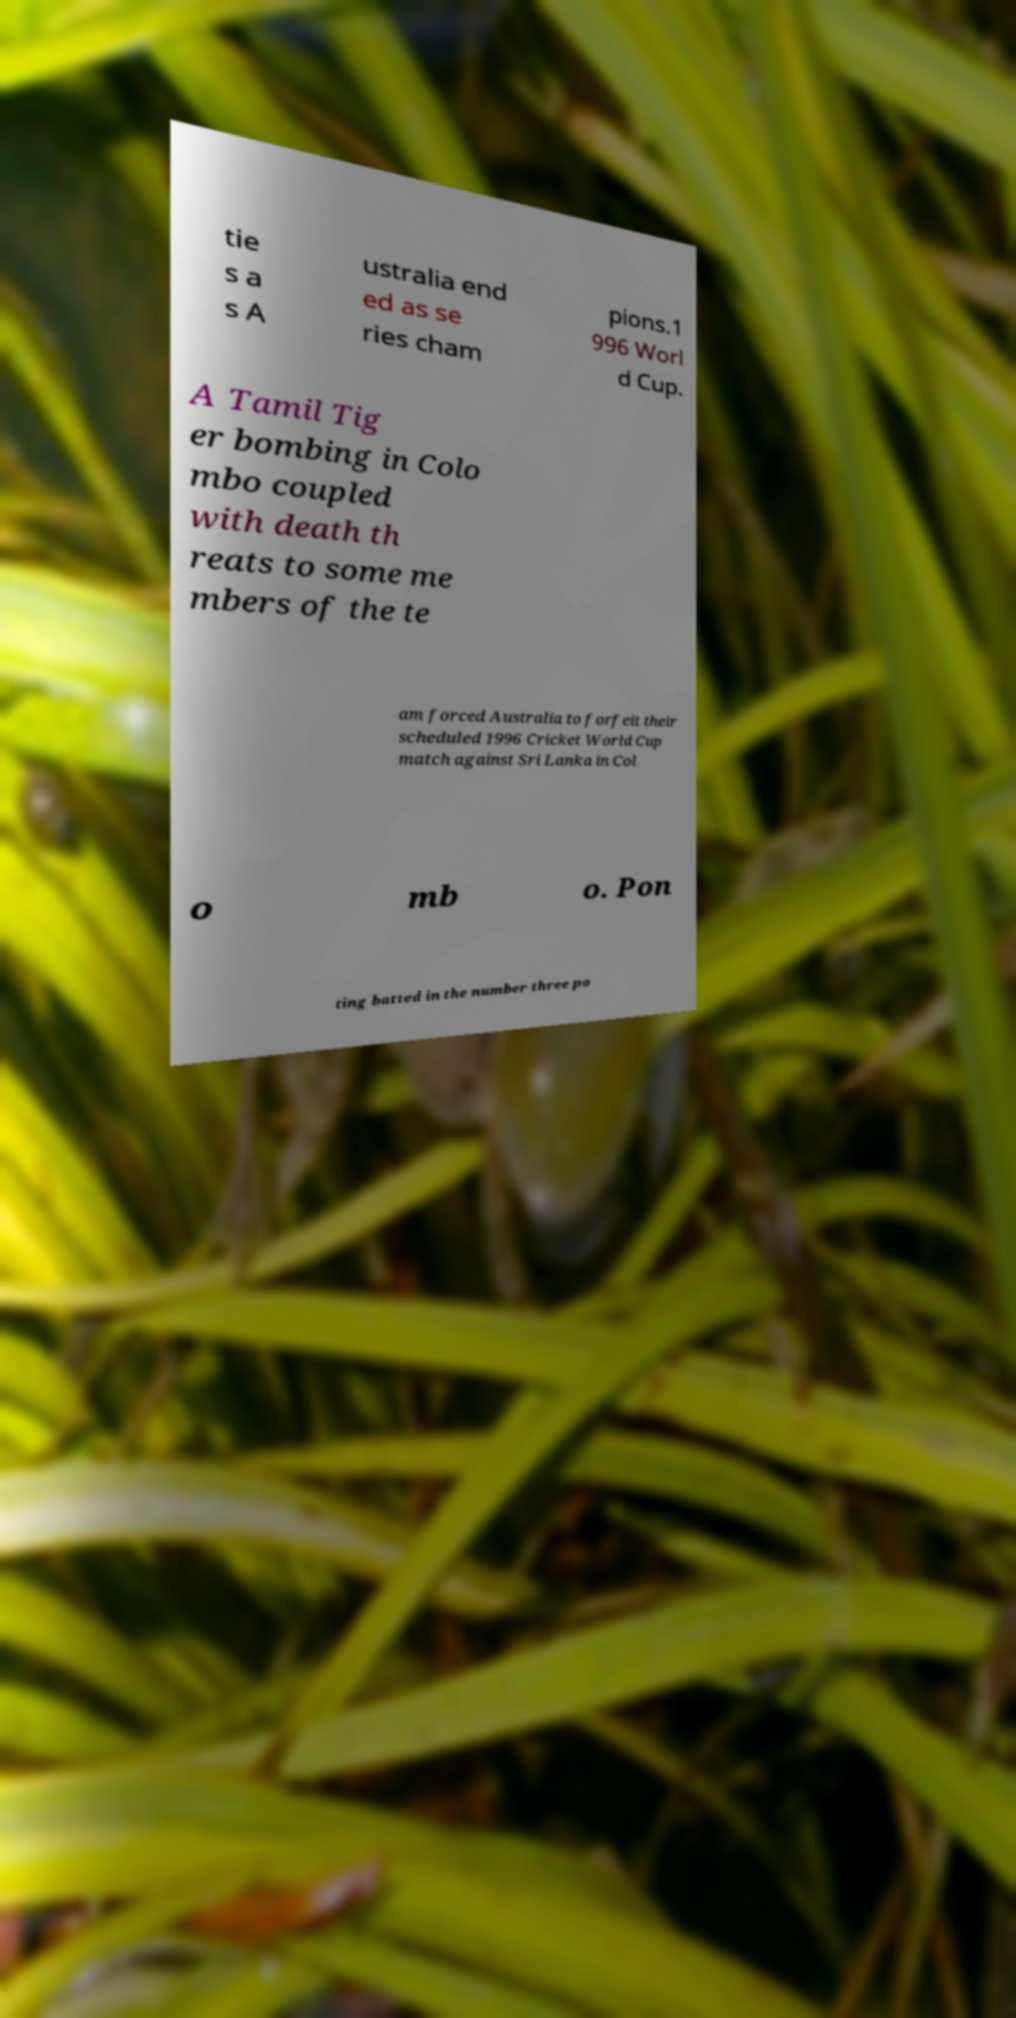For documentation purposes, I need the text within this image transcribed. Could you provide that? tie s a s A ustralia end ed as se ries cham pions.1 996 Worl d Cup. A Tamil Tig er bombing in Colo mbo coupled with death th reats to some me mbers of the te am forced Australia to forfeit their scheduled 1996 Cricket World Cup match against Sri Lanka in Col o mb o. Pon ting batted in the number three po 